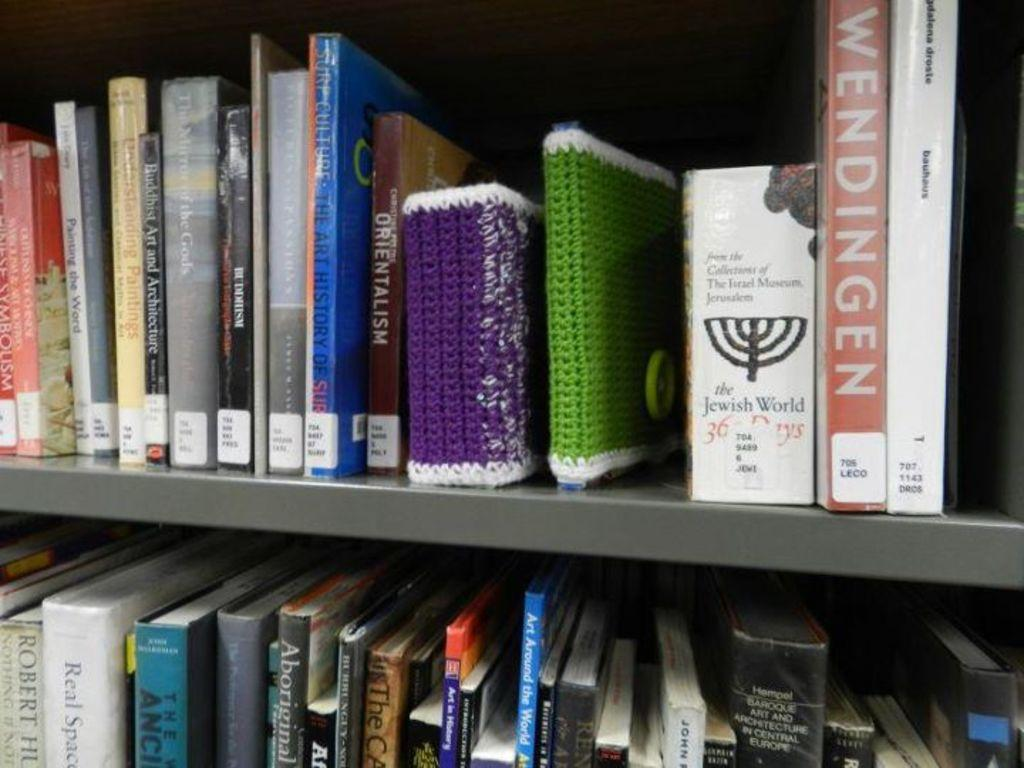<image>
Share a concise interpretation of the image provided. A library book shelf with books such as The Jewish World. 